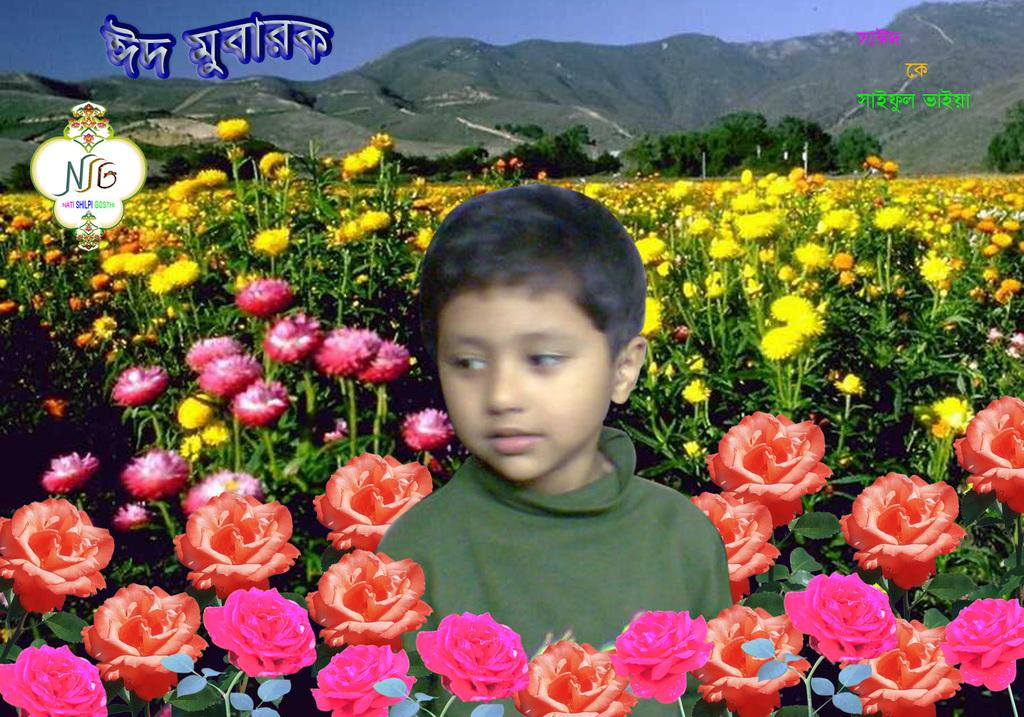What type of editing has been done to the image? The image is edited, but the specific type of editing is not mentioned in the facts. What type of vegetation can be seen in the image? There are flower plants and trees in the image. What type of landscape is visible in the image? There are hills in the image. What part of the natural environment is visible in the image? The sky is visible in the image. Who is present in the image? There is a boy in the image. Are there any watermarks in the image? Yes, there are watermarks in the image. What type of servant is attending to the boy in the image? There is no servant present in the image; it only features a boy. What type of leaf is visible on the trees in the image? The facts do not specify the type of leaves on the trees, only that there are trees in the image. 